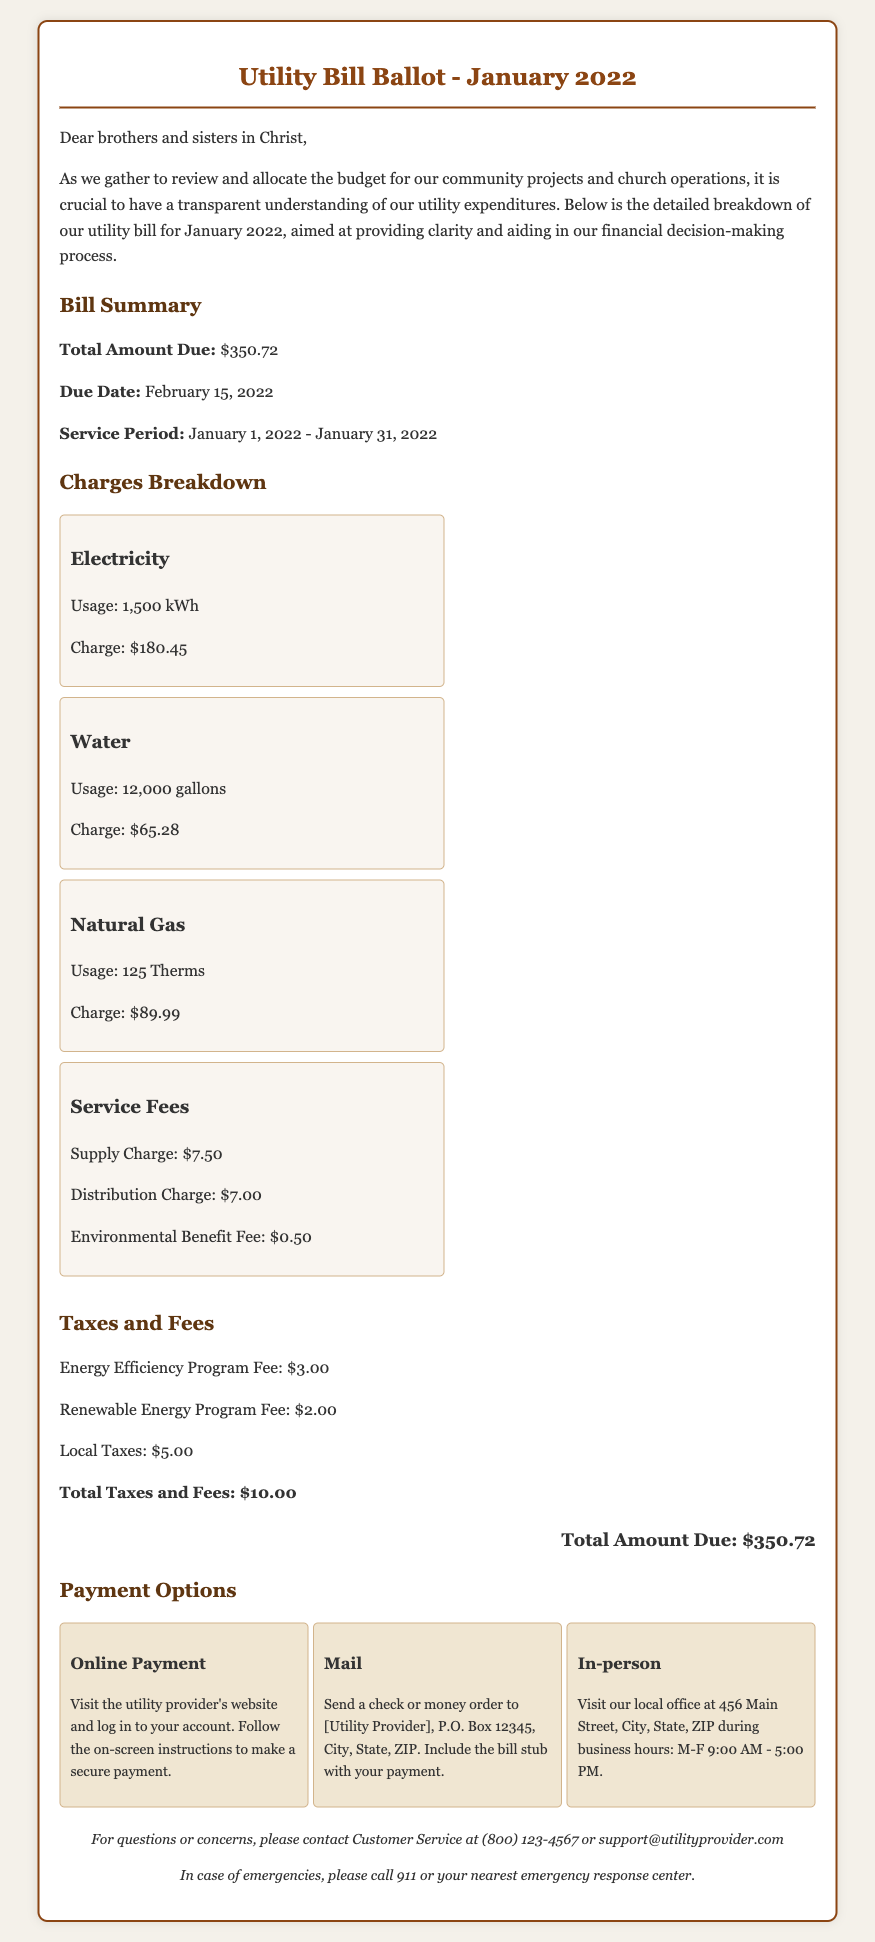what is the total amount due? The total amount due is specified in the bill summary section and totals all charges listed.
Answer: $350.72 what is the service period? The service period refers to the dates during which the utilities were used, as indicated in the bill summary section.
Answer: January 1, 2022 - January 31, 2022 how much was charged for electricity? The charge for electricity is detailed in the charges breakdown section and represents the cost for the specified usage.
Answer: $180.45 what is the due date for payment? The due date is provided in the bill summary section and indicates when the payment must be made.
Answer: February 15, 2022 what is the usage in gallons of water? The water usage is listed in the charges breakdown section and details the amount consumed during the service period.
Answer: 12,000 gallons how much were the total taxes and fees? The total taxes and fees are provided in their specific section, summarizing all applicable charges.
Answer: $10.00 what kind of payment options are available? The payment options section outlines the methods through which payment can be made, indicating various choices for the payer.
Answer: Online Payment, Mail, In-person how many therms of natural gas were used? The usage of natural gas is specified in the charges breakdown section, showing the amount consumed.
Answer: 125 Therms what is the charge for the Environmental Benefit Fee? The charge for the Environmental Benefit Fee is detailed within the service fees section of the document.
Answer: $0.50 